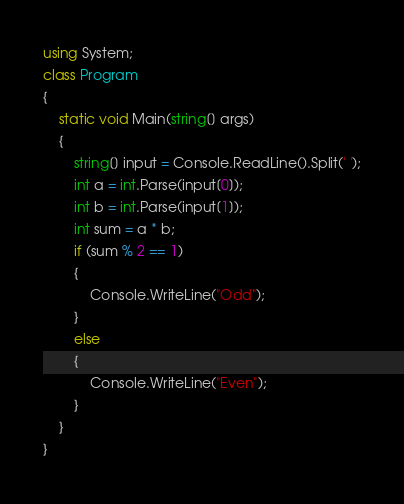<code> <loc_0><loc_0><loc_500><loc_500><_C#_>using System;
class Program
{
	static void Main(string[] args)
	{
		string[] input = Console.ReadLine().Split(' ');
		int a = int.Parse(input[0]);
		int b = int.Parse(input[1]);
		int sum = a * b;
        if (sum % 2 == 1)
        {
            Console.WriteLine("Odd");
        }
        else
        {
            Console.WriteLine("Even");
        }
	}
}</code> 